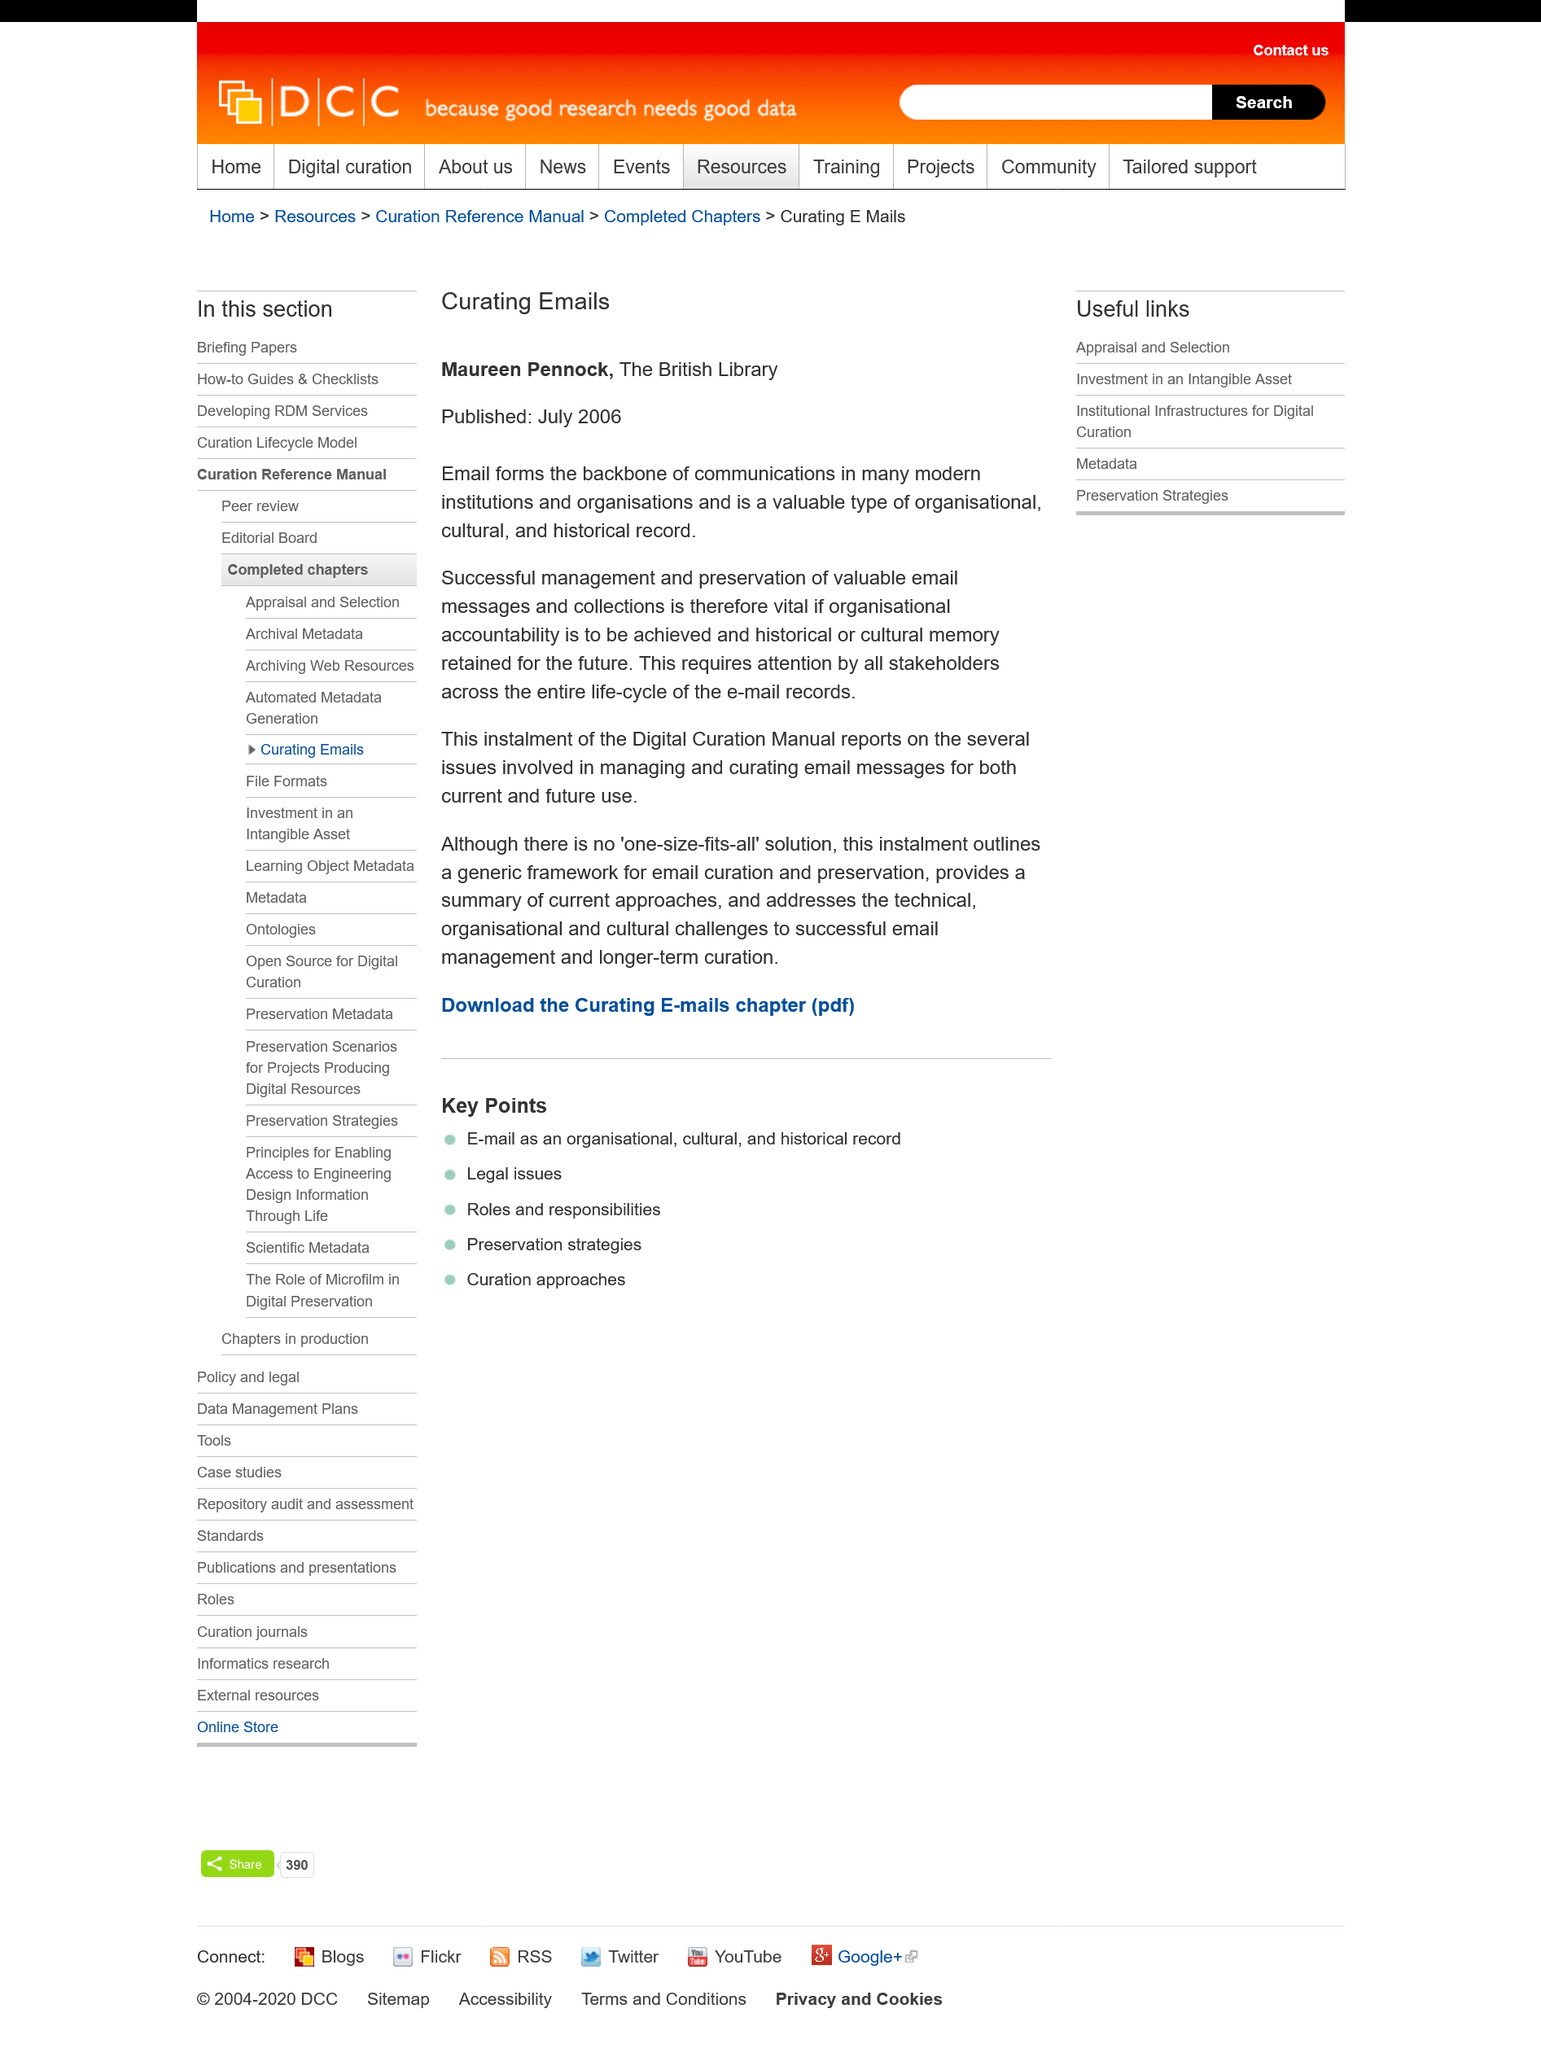Draw attention to some important aspects in this diagram. Email is a valuable type of organizational, cultural, and historical record. Email is the backbone of communication in many modern institutions. The article on curating emails was published in July 2006. 